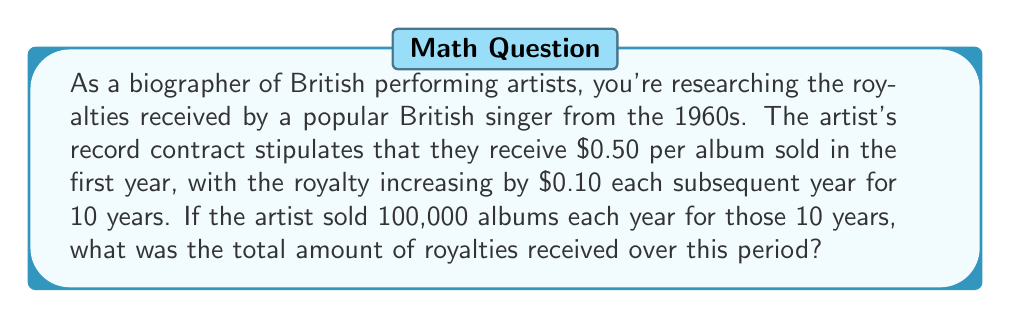Give your solution to this math problem. To solve this problem, we need to use the concept of arithmetic sequences and series. Let's break it down step-by-step:

1) The royalty per album forms an arithmetic sequence:
   Year 1: $0.50
   Year 2: $0.60
   Year 3: $0.70
   ...and so on, with a common difference of $0.10

2) We can represent this sequence as $a_n = 0.50 + 0.10(n-1)$, where $n$ is the year number.

3) The number of albums sold each year is constant at 100,000.

4) To find the total royalties, we need to calculate:
   $100,000 \times (0.50 + 0.60 + 0.70 + ... + 1.40)$

5) This is equivalent to finding the sum of an arithmetic sequence with:
   - First term $a_1 = 0.50$
   - Last term $a_{10} = 1.40$
   - Number of terms $n = 10$

6) We can use the formula for the sum of an arithmetic sequence:
   $$S_n = \frac{n}{2}(a_1 + a_n)$$

7) Plugging in our values:
   $$S_{10} = \frac{10}{2}(0.50 + 1.40) = 5(1.90) = 9.50$$

8) This $9.50 represents the sum of royalties per album over 10 years.

9) Multiplying by 100,000 albums per year:
   $100,000 \times 9.50 = 950,000$

Therefore, the total royalties received over the 10-year period is $950,000.
Answer: $950,000 